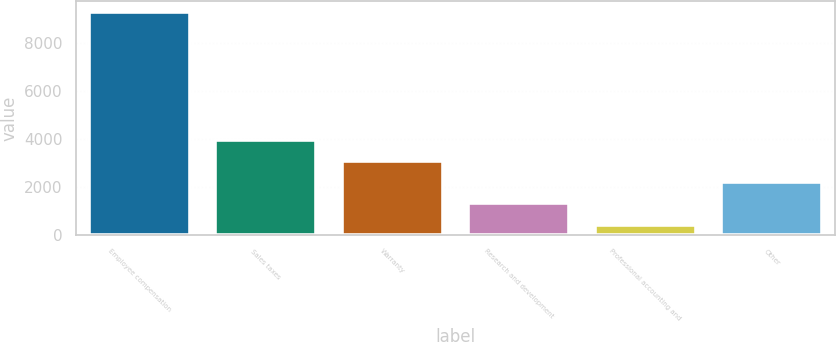Convert chart to OTSL. <chart><loc_0><loc_0><loc_500><loc_500><bar_chart><fcel>Employee compensation<fcel>Sales taxes<fcel>Warranty<fcel>Research and development<fcel>Professional accounting and<fcel>Other<nl><fcel>9272<fcel>3965<fcel>3080.5<fcel>1311.5<fcel>427<fcel>2196<nl></chart> 